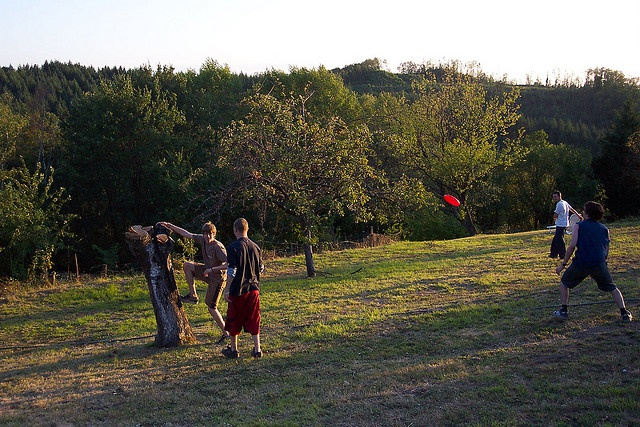Describe the objects in this image and their specific colors. I can see people in lavender, black, maroon, and gray tones, people in lavender, black, navy, gray, and purple tones, people in lavender, black, maroon, gray, and purple tones, people in lavender, black, gray, and white tones, and frisbee in lavender, red, brown, black, and maroon tones in this image. 